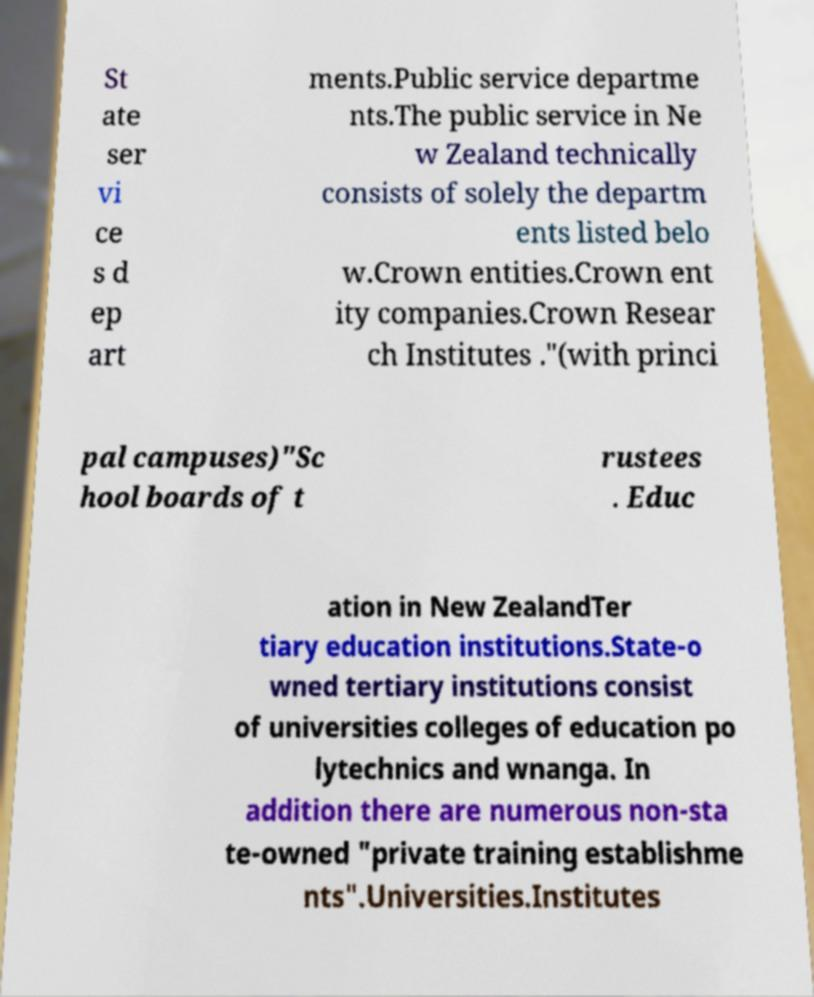I need the written content from this picture converted into text. Can you do that? St ate ser vi ce s d ep art ments.Public service departme nts.The public service in Ne w Zealand technically consists of solely the departm ents listed belo w.Crown entities.Crown ent ity companies.Crown Resear ch Institutes ."(with princi pal campuses)"Sc hool boards of t rustees . Educ ation in New ZealandTer tiary education institutions.State-o wned tertiary institutions consist of universities colleges of education po lytechnics and wnanga. In addition there are numerous non-sta te-owned "private training establishme nts".Universities.Institutes 